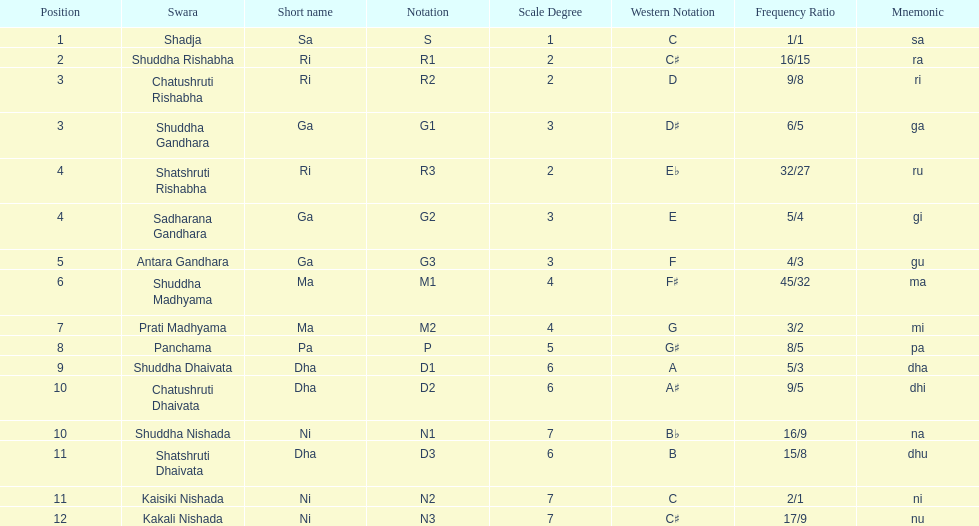Which swara follows immediately after antara gandhara? Shuddha Madhyama. 